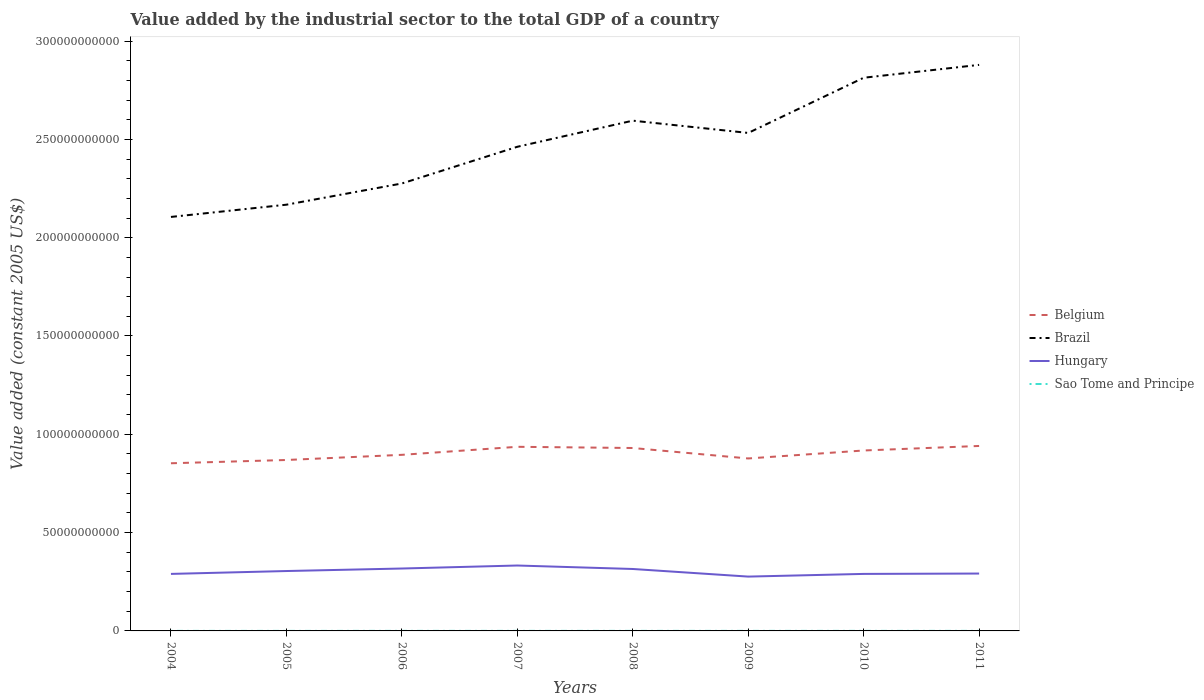How many different coloured lines are there?
Your answer should be very brief. 4. Does the line corresponding to Brazil intersect with the line corresponding to Hungary?
Offer a very short reply. No. Is the number of lines equal to the number of legend labels?
Keep it short and to the point. Yes. Across all years, what is the maximum value added by the industrial sector in Sao Tome and Principe?
Make the answer very short. 1.82e+07. In which year was the value added by the industrial sector in Sao Tome and Principe maximum?
Provide a short and direct response. 2004. What is the total value added by the industrial sector in Hungary in the graph?
Offer a very short reply. 4.04e+06. What is the difference between the highest and the second highest value added by the industrial sector in Hungary?
Provide a succinct answer. 5.64e+09. What is the difference between the highest and the lowest value added by the industrial sector in Brazil?
Make the answer very short. 4. How many lines are there?
Your response must be concise. 4. How many years are there in the graph?
Your answer should be very brief. 8. What is the difference between two consecutive major ticks on the Y-axis?
Your response must be concise. 5.00e+1. Are the values on the major ticks of Y-axis written in scientific E-notation?
Provide a short and direct response. No. Does the graph contain grids?
Offer a terse response. No. Where does the legend appear in the graph?
Your response must be concise. Center right. What is the title of the graph?
Your response must be concise. Value added by the industrial sector to the total GDP of a country. What is the label or title of the X-axis?
Keep it short and to the point. Years. What is the label or title of the Y-axis?
Your response must be concise. Value added (constant 2005 US$). What is the Value added (constant 2005 US$) of Belgium in 2004?
Offer a very short reply. 8.53e+1. What is the Value added (constant 2005 US$) in Brazil in 2004?
Make the answer very short. 2.11e+11. What is the Value added (constant 2005 US$) of Hungary in 2004?
Your answer should be compact. 2.90e+1. What is the Value added (constant 2005 US$) in Sao Tome and Principe in 2004?
Offer a terse response. 1.82e+07. What is the Value added (constant 2005 US$) of Belgium in 2005?
Your answer should be compact. 8.69e+1. What is the Value added (constant 2005 US$) in Brazil in 2005?
Ensure brevity in your answer.  2.17e+11. What is the Value added (constant 2005 US$) in Hungary in 2005?
Provide a short and direct response. 3.05e+1. What is the Value added (constant 2005 US$) of Sao Tome and Principe in 2005?
Offer a terse response. 1.89e+07. What is the Value added (constant 2005 US$) of Belgium in 2006?
Make the answer very short. 8.96e+1. What is the Value added (constant 2005 US$) in Brazil in 2006?
Provide a short and direct response. 2.28e+11. What is the Value added (constant 2005 US$) of Hungary in 2006?
Your answer should be very brief. 3.17e+1. What is the Value added (constant 2005 US$) in Sao Tome and Principe in 2006?
Keep it short and to the point. 2.01e+07. What is the Value added (constant 2005 US$) of Belgium in 2007?
Keep it short and to the point. 9.36e+1. What is the Value added (constant 2005 US$) in Brazil in 2007?
Make the answer very short. 2.46e+11. What is the Value added (constant 2005 US$) of Hungary in 2007?
Your answer should be compact. 3.33e+1. What is the Value added (constant 2005 US$) of Sao Tome and Principe in 2007?
Ensure brevity in your answer.  2.07e+07. What is the Value added (constant 2005 US$) in Belgium in 2008?
Provide a succinct answer. 9.30e+1. What is the Value added (constant 2005 US$) of Brazil in 2008?
Make the answer very short. 2.60e+11. What is the Value added (constant 2005 US$) in Hungary in 2008?
Make the answer very short. 3.15e+1. What is the Value added (constant 2005 US$) of Sao Tome and Principe in 2008?
Your answer should be very brief. 2.19e+07. What is the Value added (constant 2005 US$) of Belgium in 2009?
Offer a very short reply. 8.77e+1. What is the Value added (constant 2005 US$) of Brazil in 2009?
Ensure brevity in your answer.  2.53e+11. What is the Value added (constant 2005 US$) of Hungary in 2009?
Your response must be concise. 2.76e+1. What is the Value added (constant 2005 US$) of Sao Tome and Principe in 2009?
Offer a very short reply. 2.21e+07. What is the Value added (constant 2005 US$) in Belgium in 2010?
Offer a terse response. 9.18e+1. What is the Value added (constant 2005 US$) of Brazil in 2010?
Your response must be concise. 2.81e+11. What is the Value added (constant 2005 US$) of Hungary in 2010?
Keep it short and to the point. 2.90e+1. What is the Value added (constant 2005 US$) of Sao Tome and Principe in 2010?
Your response must be concise. 2.26e+07. What is the Value added (constant 2005 US$) in Belgium in 2011?
Your answer should be very brief. 9.41e+1. What is the Value added (constant 2005 US$) in Brazil in 2011?
Your answer should be compact. 2.88e+11. What is the Value added (constant 2005 US$) in Hungary in 2011?
Provide a succinct answer. 2.92e+1. What is the Value added (constant 2005 US$) of Sao Tome and Principe in 2011?
Give a very brief answer. 2.38e+07. Across all years, what is the maximum Value added (constant 2005 US$) of Belgium?
Make the answer very short. 9.41e+1. Across all years, what is the maximum Value added (constant 2005 US$) of Brazil?
Make the answer very short. 2.88e+11. Across all years, what is the maximum Value added (constant 2005 US$) in Hungary?
Provide a short and direct response. 3.33e+1. Across all years, what is the maximum Value added (constant 2005 US$) in Sao Tome and Principe?
Provide a short and direct response. 2.38e+07. Across all years, what is the minimum Value added (constant 2005 US$) of Belgium?
Your response must be concise. 8.53e+1. Across all years, what is the minimum Value added (constant 2005 US$) in Brazil?
Your answer should be very brief. 2.11e+11. Across all years, what is the minimum Value added (constant 2005 US$) of Hungary?
Your response must be concise. 2.76e+1. Across all years, what is the minimum Value added (constant 2005 US$) in Sao Tome and Principe?
Your response must be concise. 1.82e+07. What is the total Value added (constant 2005 US$) of Belgium in the graph?
Make the answer very short. 7.22e+11. What is the total Value added (constant 2005 US$) of Brazil in the graph?
Provide a short and direct response. 1.98e+12. What is the total Value added (constant 2005 US$) in Hungary in the graph?
Keep it short and to the point. 2.42e+11. What is the total Value added (constant 2005 US$) of Sao Tome and Principe in the graph?
Your answer should be very brief. 1.68e+08. What is the difference between the Value added (constant 2005 US$) in Belgium in 2004 and that in 2005?
Provide a succinct answer. -1.67e+09. What is the difference between the Value added (constant 2005 US$) in Brazil in 2004 and that in 2005?
Provide a short and direct response. -6.22e+09. What is the difference between the Value added (constant 2005 US$) of Hungary in 2004 and that in 2005?
Make the answer very short. -1.46e+09. What is the difference between the Value added (constant 2005 US$) in Sao Tome and Principe in 2004 and that in 2005?
Give a very brief answer. -6.98e+05. What is the difference between the Value added (constant 2005 US$) of Belgium in 2004 and that in 2006?
Give a very brief answer. -4.29e+09. What is the difference between the Value added (constant 2005 US$) of Brazil in 2004 and that in 2006?
Your response must be concise. -1.70e+1. What is the difference between the Value added (constant 2005 US$) of Hungary in 2004 and that in 2006?
Your response must be concise. -2.74e+09. What is the difference between the Value added (constant 2005 US$) of Sao Tome and Principe in 2004 and that in 2006?
Provide a succinct answer. -1.91e+06. What is the difference between the Value added (constant 2005 US$) in Belgium in 2004 and that in 2007?
Your answer should be compact. -8.37e+09. What is the difference between the Value added (constant 2005 US$) of Brazil in 2004 and that in 2007?
Give a very brief answer. -3.57e+1. What is the difference between the Value added (constant 2005 US$) in Hungary in 2004 and that in 2007?
Give a very brief answer. -4.27e+09. What is the difference between the Value added (constant 2005 US$) of Sao Tome and Principe in 2004 and that in 2007?
Make the answer very short. -2.48e+06. What is the difference between the Value added (constant 2005 US$) of Belgium in 2004 and that in 2008?
Your answer should be compact. -7.76e+09. What is the difference between the Value added (constant 2005 US$) in Brazil in 2004 and that in 2008?
Keep it short and to the point. -4.90e+1. What is the difference between the Value added (constant 2005 US$) in Hungary in 2004 and that in 2008?
Ensure brevity in your answer.  -2.50e+09. What is the difference between the Value added (constant 2005 US$) in Sao Tome and Principe in 2004 and that in 2008?
Ensure brevity in your answer.  -3.69e+06. What is the difference between the Value added (constant 2005 US$) of Belgium in 2004 and that in 2009?
Give a very brief answer. -2.44e+09. What is the difference between the Value added (constant 2005 US$) in Brazil in 2004 and that in 2009?
Your answer should be compact. -4.27e+1. What is the difference between the Value added (constant 2005 US$) of Hungary in 2004 and that in 2009?
Provide a succinct answer. 1.37e+09. What is the difference between the Value added (constant 2005 US$) of Sao Tome and Principe in 2004 and that in 2009?
Your answer should be very brief. -3.84e+06. What is the difference between the Value added (constant 2005 US$) of Belgium in 2004 and that in 2010?
Ensure brevity in your answer.  -6.50e+09. What is the difference between the Value added (constant 2005 US$) of Brazil in 2004 and that in 2010?
Offer a very short reply. -7.08e+1. What is the difference between the Value added (constant 2005 US$) in Hungary in 2004 and that in 2010?
Offer a very short reply. 4.04e+06. What is the difference between the Value added (constant 2005 US$) of Sao Tome and Principe in 2004 and that in 2010?
Give a very brief answer. -4.36e+06. What is the difference between the Value added (constant 2005 US$) of Belgium in 2004 and that in 2011?
Your response must be concise. -8.80e+09. What is the difference between the Value added (constant 2005 US$) in Brazil in 2004 and that in 2011?
Your answer should be compact. -7.73e+1. What is the difference between the Value added (constant 2005 US$) of Hungary in 2004 and that in 2011?
Offer a very short reply. -1.81e+08. What is the difference between the Value added (constant 2005 US$) in Sao Tome and Principe in 2004 and that in 2011?
Keep it short and to the point. -5.57e+06. What is the difference between the Value added (constant 2005 US$) of Belgium in 2005 and that in 2006?
Your response must be concise. -2.62e+09. What is the difference between the Value added (constant 2005 US$) in Brazil in 2005 and that in 2006?
Your response must be concise. -1.08e+1. What is the difference between the Value added (constant 2005 US$) in Hungary in 2005 and that in 2006?
Provide a succinct answer. -1.28e+09. What is the difference between the Value added (constant 2005 US$) of Sao Tome and Principe in 2005 and that in 2006?
Provide a succinct answer. -1.22e+06. What is the difference between the Value added (constant 2005 US$) in Belgium in 2005 and that in 2007?
Your answer should be compact. -6.70e+09. What is the difference between the Value added (constant 2005 US$) of Brazil in 2005 and that in 2007?
Your response must be concise. -2.95e+1. What is the difference between the Value added (constant 2005 US$) in Hungary in 2005 and that in 2007?
Ensure brevity in your answer.  -2.81e+09. What is the difference between the Value added (constant 2005 US$) of Sao Tome and Principe in 2005 and that in 2007?
Provide a short and direct response. -1.78e+06. What is the difference between the Value added (constant 2005 US$) of Belgium in 2005 and that in 2008?
Offer a very short reply. -6.09e+09. What is the difference between the Value added (constant 2005 US$) in Brazil in 2005 and that in 2008?
Offer a terse response. -4.27e+1. What is the difference between the Value added (constant 2005 US$) in Hungary in 2005 and that in 2008?
Keep it short and to the point. -1.04e+09. What is the difference between the Value added (constant 2005 US$) of Sao Tome and Principe in 2005 and that in 2008?
Keep it short and to the point. -2.99e+06. What is the difference between the Value added (constant 2005 US$) in Belgium in 2005 and that in 2009?
Keep it short and to the point. -7.76e+08. What is the difference between the Value added (constant 2005 US$) of Brazil in 2005 and that in 2009?
Your response must be concise. -3.65e+1. What is the difference between the Value added (constant 2005 US$) in Hungary in 2005 and that in 2009?
Keep it short and to the point. 2.83e+09. What is the difference between the Value added (constant 2005 US$) in Sao Tome and Principe in 2005 and that in 2009?
Your response must be concise. -3.15e+06. What is the difference between the Value added (constant 2005 US$) in Belgium in 2005 and that in 2010?
Offer a terse response. -4.83e+09. What is the difference between the Value added (constant 2005 US$) in Brazil in 2005 and that in 2010?
Keep it short and to the point. -6.46e+1. What is the difference between the Value added (constant 2005 US$) in Hungary in 2005 and that in 2010?
Provide a succinct answer. 1.47e+09. What is the difference between the Value added (constant 2005 US$) of Sao Tome and Principe in 2005 and that in 2010?
Offer a terse response. -3.66e+06. What is the difference between the Value added (constant 2005 US$) of Belgium in 2005 and that in 2011?
Your answer should be compact. -7.14e+09. What is the difference between the Value added (constant 2005 US$) in Brazil in 2005 and that in 2011?
Your answer should be very brief. -7.11e+1. What is the difference between the Value added (constant 2005 US$) in Hungary in 2005 and that in 2011?
Ensure brevity in your answer.  1.28e+09. What is the difference between the Value added (constant 2005 US$) of Sao Tome and Principe in 2005 and that in 2011?
Offer a very short reply. -4.87e+06. What is the difference between the Value added (constant 2005 US$) in Belgium in 2006 and that in 2007?
Your answer should be very brief. -4.08e+09. What is the difference between the Value added (constant 2005 US$) in Brazil in 2006 and that in 2007?
Give a very brief answer. -1.87e+1. What is the difference between the Value added (constant 2005 US$) in Hungary in 2006 and that in 2007?
Give a very brief answer. -1.53e+09. What is the difference between the Value added (constant 2005 US$) of Sao Tome and Principe in 2006 and that in 2007?
Give a very brief answer. -5.69e+05. What is the difference between the Value added (constant 2005 US$) in Belgium in 2006 and that in 2008?
Provide a short and direct response. -3.47e+09. What is the difference between the Value added (constant 2005 US$) of Brazil in 2006 and that in 2008?
Make the answer very short. -3.19e+1. What is the difference between the Value added (constant 2005 US$) of Hungary in 2006 and that in 2008?
Provide a succinct answer. 2.40e+08. What is the difference between the Value added (constant 2005 US$) in Sao Tome and Principe in 2006 and that in 2008?
Offer a very short reply. -1.78e+06. What is the difference between the Value added (constant 2005 US$) in Belgium in 2006 and that in 2009?
Your answer should be very brief. 1.84e+09. What is the difference between the Value added (constant 2005 US$) of Brazil in 2006 and that in 2009?
Your response must be concise. -2.57e+1. What is the difference between the Value added (constant 2005 US$) in Hungary in 2006 and that in 2009?
Offer a very short reply. 4.11e+09. What is the difference between the Value added (constant 2005 US$) in Sao Tome and Principe in 2006 and that in 2009?
Make the answer very short. -1.93e+06. What is the difference between the Value added (constant 2005 US$) of Belgium in 2006 and that in 2010?
Ensure brevity in your answer.  -2.21e+09. What is the difference between the Value added (constant 2005 US$) of Brazil in 2006 and that in 2010?
Your response must be concise. -5.38e+1. What is the difference between the Value added (constant 2005 US$) of Hungary in 2006 and that in 2010?
Your answer should be compact. 2.75e+09. What is the difference between the Value added (constant 2005 US$) in Sao Tome and Principe in 2006 and that in 2010?
Keep it short and to the point. -2.44e+06. What is the difference between the Value added (constant 2005 US$) of Belgium in 2006 and that in 2011?
Your answer should be very brief. -4.51e+09. What is the difference between the Value added (constant 2005 US$) in Brazil in 2006 and that in 2011?
Provide a succinct answer. -6.03e+1. What is the difference between the Value added (constant 2005 US$) of Hungary in 2006 and that in 2011?
Make the answer very short. 2.56e+09. What is the difference between the Value added (constant 2005 US$) in Sao Tome and Principe in 2006 and that in 2011?
Your answer should be compact. -3.65e+06. What is the difference between the Value added (constant 2005 US$) of Belgium in 2007 and that in 2008?
Make the answer very short. 6.09e+08. What is the difference between the Value added (constant 2005 US$) of Brazil in 2007 and that in 2008?
Provide a short and direct response. -1.33e+1. What is the difference between the Value added (constant 2005 US$) in Hungary in 2007 and that in 2008?
Offer a terse response. 1.77e+09. What is the difference between the Value added (constant 2005 US$) in Sao Tome and Principe in 2007 and that in 2008?
Offer a terse response. -1.21e+06. What is the difference between the Value added (constant 2005 US$) in Belgium in 2007 and that in 2009?
Provide a short and direct response. 5.93e+09. What is the difference between the Value added (constant 2005 US$) in Brazil in 2007 and that in 2009?
Provide a succinct answer. -7.04e+09. What is the difference between the Value added (constant 2005 US$) in Hungary in 2007 and that in 2009?
Your answer should be very brief. 5.64e+09. What is the difference between the Value added (constant 2005 US$) in Sao Tome and Principe in 2007 and that in 2009?
Offer a very short reply. -1.36e+06. What is the difference between the Value added (constant 2005 US$) of Belgium in 2007 and that in 2010?
Your answer should be very brief. 1.87e+09. What is the difference between the Value added (constant 2005 US$) in Brazil in 2007 and that in 2010?
Keep it short and to the point. -3.51e+1. What is the difference between the Value added (constant 2005 US$) in Hungary in 2007 and that in 2010?
Your response must be concise. 4.27e+09. What is the difference between the Value added (constant 2005 US$) of Sao Tome and Principe in 2007 and that in 2010?
Keep it short and to the point. -1.87e+06. What is the difference between the Value added (constant 2005 US$) of Belgium in 2007 and that in 2011?
Your answer should be compact. -4.31e+08. What is the difference between the Value added (constant 2005 US$) of Brazil in 2007 and that in 2011?
Offer a very short reply. -4.17e+1. What is the difference between the Value added (constant 2005 US$) in Hungary in 2007 and that in 2011?
Provide a short and direct response. 4.09e+09. What is the difference between the Value added (constant 2005 US$) of Sao Tome and Principe in 2007 and that in 2011?
Make the answer very short. -3.09e+06. What is the difference between the Value added (constant 2005 US$) of Belgium in 2008 and that in 2009?
Your response must be concise. 5.32e+09. What is the difference between the Value added (constant 2005 US$) of Brazil in 2008 and that in 2009?
Your response must be concise. 6.24e+09. What is the difference between the Value added (constant 2005 US$) of Hungary in 2008 and that in 2009?
Offer a very short reply. 3.87e+09. What is the difference between the Value added (constant 2005 US$) of Sao Tome and Principe in 2008 and that in 2009?
Offer a terse response. -1.52e+05. What is the difference between the Value added (constant 2005 US$) in Belgium in 2008 and that in 2010?
Keep it short and to the point. 1.26e+09. What is the difference between the Value added (constant 2005 US$) in Brazil in 2008 and that in 2010?
Provide a succinct answer. -2.18e+1. What is the difference between the Value added (constant 2005 US$) in Hungary in 2008 and that in 2010?
Offer a terse response. 2.51e+09. What is the difference between the Value added (constant 2005 US$) in Sao Tome and Principe in 2008 and that in 2010?
Offer a very short reply. -6.63e+05. What is the difference between the Value added (constant 2005 US$) in Belgium in 2008 and that in 2011?
Give a very brief answer. -1.04e+09. What is the difference between the Value added (constant 2005 US$) of Brazil in 2008 and that in 2011?
Offer a very short reply. -2.84e+1. What is the difference between the Value added (constant 2005 US$) of Hungary in 2008 and that in 2011?
Make the answer very short. 2.32e+09. What is the difference between the Value added (constant 2005 US$) of Sao Tome and Principe in 2008 and that in 2011?
Provide a succinct answer. -1.88e+06. What is the difference between the Value added (constant 2005 US$) of Belgium in 2009 and that in 2010?
Your answer should be very brief. -4.05e+09. What is the difference between the Value added (constant 2005 US$) of Brazil in 2009 and that in 2010?
Your answer should be compact. -2.81e+1. What is the difference between the Value added (constant 2005 US$) in Hungary in 2009 and that in 2010?
Your response must be concise. -1.37e+09. What is the difference between the Value added (constant 2005 US$) of Sao Tome and Principe in 2009 and that in 2010?
Offer a very short reply. -5.12e+05. What is the difference between the Value added (constant 2005 US$) in Belgium in 2009 and that in 2011?
Keep it short and to the point. -6.36e+09. What is the difference between the Value added (constant 2005 US$) of Brazil in 2009 and that in 2011?
Give a very brief answer. -3.46e+1. What is the difference between the Value added (constant 2005 US$) in Hungary in 2009 and that in 2011?
Make the answer very short. -1.55e+09. What is the difference between the Value added (constant 2005 US$) of Sao Tome and Principe in 2009 and that in 2011?
Provide a succinct answer. -1.72e+06. What is the difference between the Value added (constant 2005 US$) in Belgium in 2010 and that in 2011?
Offer a very short reply. -2.30e+09. What is the difference between the Value added (constant 2005 US$) in Brazil in 2010 and that in 2011?
Ensure brevity in your answer.  -6.54e+09. What is the difference between the Value added (constant 2005 US$) in Hungary in 2010 and that in 2011?
Offer a terse response. -1.85e+08. What is the difference between the Value added (constant 2005 US$) of Sao Tome and Principe in 2010 and that in 2011?
Provide a succinct answer. -1.21e+06. What is the difference between the Value added (constant 2005 US$) of Belgium in 2004 and the Value added (constant 2005 US$) of Brazil in 2005?
Keep it short and to the point. -1.32e+11. What is the difference between the Value added (constant 2005 US$) of Belgium in 2004 and the Value added (constant 2005 US$) of Hungary in 2005?
Ensure brevity in your answer.  5.48e+1. What is the difference between the Value added (constant 2005 US$) of Belgium in 2004 and the Value added (constant 2005 US$) of Sao Tome and Principe in 2005?
Ensure brevity in your answer.  8.52e+1. What is the difference between the Value added (constant 2005 US$) of Brazil in 2004 and the Value added (constant 2005 US$) of Hungary in 2005?
Offer a terse response. 1.80e+11. What is the difference between the Value added (constant 2005 US$) in Brazil in 2004 and the Value added (constant 2005 US$) in Sao Tome and Principe in 2005?
Your answer should be compact. 2.11e+11. What is the difference between the Value added (constant 2005 US$) in Hungary in 2004 and the Value added (constant 2005 US$) in Sao Tome and Principe in 2005?
Offer a very short reply. 2.90e+1. What is the difference between the Value added (constant 2005 US$) of Belgium in 2004 and the Value added (constant 2005 US$) of Brazil in 2006?
Provide a succinct answer. -1.42e+11. What is the difference between the Value added (constant 2005 US$) in Belgium in 2004 and the Value added (constant 2005 US$) in Hungary in 2006?
Keep it short and to the point. 5.35e+1. What is the difference between the Value added (constant 2005 US$) of Belgium in 2004 and the Value added (constant 2005 US$) of Sao Tome and Principe in 2006?
Ensure brevity in your answer.  8.52e+1. What is the difference between the Value added (constant 2005 US$) of Brazil in 2004 and the Value added (constant 2005 US$) of Hungary in 2006?
Your answer should be compact. 1.79e+11. What is the difference between the Value added (constant 2005 US$) of Brazil in 2004 and the Value added (constant 2005 US$) of Sao Tome and Principe in 2006?
Your response must be concise. 2.11e+11. What is the difference between the Value added (constant 2005 US$) in Hungary in 2004 and the Value added (constant 2005 US$) in Sao Tome and Principe in 2006?
Your response must be concise. 2.90e+1. What is the difference between the Value added (constant 2005 US$) of Belgium in 2004 and the Value added (constant 2005 US$) of Brazil in 2007?
Keep it short and to the point. -1.61e+11. What is the difference between the Value added (constant 2005 US$) of Belgium in 2004 and the Value added (constant 2005 US$) of Hungary in 2007?
Offer a terse response. 5.20e+1. What is the difference between the Value added (constant 2005 US$) of Belgium in 2004 and the Value added (constant 2005 US$) of Sao Tome and Principe in 2007?
Your answer should be compact. 8.52e+1. What is the difference between the Value added (constant 2005 US$) in Brazil in 2004 and the Value added (constant 2005 US$) in Hungary in 2007?
Your response must be concise. 1.77e+11. What is the difference between the Value added (constant 2005 US$) in Brazil in 2004 and the Value added (constant 2005 US$) in Sao Tome and Principe in 2007?
Make the answer very short. 2.11e+11. What is the difference between the Value added (constant 2005 US$) in Hungary in 2004 and the Value added (constant 2005 US$) in Sao Tome and Principe in 2007?
Offer a terse response. 2.90e+1. What is the difference between the Value added (constant 2005 US$) of Belgium in 2004 and the Value added (constant 2005 US$) of Brazil in 2008?
Keep it short and to the point. -1.74e+11. What is the difference between the Value added (constant 2005 US$) of Belgium in 2004 and the Value added (constant 2005 US$) of Hungary in 2008?
Offer a very short reply. 5.38e+1. What is the difference between the Value added (constant 2005 US$) of Belgium in 2004 and the Value added (constant 2005 US$) of Sao Tome and Principe in 2008?
Offer a terse response. 8.52e+1. What is the difference between the Value added (constant 2005 US$) in Brazil in 2004 and the Value added (constant 2005 US$) in Hungary in 2008?
Offer a very short reply. 1.79e+11. What is the difference between the Value added (constant 2005 US$) in Brazil in 2004 and the Value added (constant 2005 US$) in Sao Tome and Principe in 2008?
Make the answer very short. 2.11e+11. What is the difference between the Value added (constant 2005 US$) in Hungary in 2004 and the Value added (constant 2005 US$) in Sao Tome and Principe in 2008?
Your answer should be compact. 2.90e+1. What is the difference between the Value added (constant 2005 US$) in Belgium in 2004 and the Value added (constant 2005 US$) in Brazil in 2009?
Give a very brief answer. -1.68e+11. What is the difference between the Value added (constant 2005 US$) in Belgium in 2004 and the Value added (constant 2005 US$) in Hungary in 2009?
Provide a succinct answer. 5.76e+1. What is the difference between the Value added (constant 2005 US$) in Belgium in 2004 and the Value added (constant 2005 US$) in Sao Tome and Principe in 2009?
Give a very brief answer. 8.52e+1. What is the difference between the Value added (constant 2005 US$) in Brazil in 2004 and the Value added (constant 2005 US$) in Hungary in 2009?
Provide a succinct answer. 1.83e+11. What is the difference between the Value added (constant 2005 US$) of Brazil in 2004 and the Value added (constant 2005 US$) of Sao Tome and Principe in 2009?
Provide a short and direct response. 2.11e+11. What is the difference between the Value added (constant 2005 US$) of Hungary in 2004 and the Value added (constant 2005 US$) of Sao Tome and Principe in 2009?
Your answer should be very brief. 2.90e+1. What is the difference between the Value added (constant 2005 US$) in Belgium in 2004 and the Value added (constant 2005 US$) in Brazil in 2010?
Your response must be concise. -1.96e+11. What is the difference between the Value added (constant 2005 US$) in Belgium in 2004 and the Value added (constant 2005 US$) in Hungary in 2010?
Your answer should be compact. 5.63e+1. What is the difference between the Value added (constant 2005 US$) of Belgium in 2004 and the Value added (constant 2005 US$) of Sao Tome and Principe in 2010?
Provide a short and direct response. 8.52e+1. What is the difference between the Value added (constant 2005 US$) in Brazil in 2004 and the Value added (constant 2005 US$) in Hungary in 2010?
Provide a short and direct response. 1.82e+11. What is the difference between the Value added (constant 2005 US$) of Brazil in 2004 and the Value added (constant 2005 US$) of Sao Tome and Principe in 2010?
Give a very brief answer. 2.11e+11. What is the difference between the Value added (constant 2005 US$) of Hungary in 2004 and the Value added (constant 2005 US$) of Sao Tome and Principe in 2010?
Offer a terse response. 2.90e+1. What is the difference between the Value added (constant 2005 US$) in Belgium in 2004 and the Value added (constant 2005 US$) in Brazil in 2011?
Provide a short and direct response. -2.03e+11. What is the difference between the Value added (constant 2005 US$) of Belgium in 2004 and the Value added (constant 2005 US$) of Hungary in 2011?
Offer a terse response. 5.61e+1. What is the difference between the Value added (constant 2005 US$) of Belgium in 2004 and the Value added (constant 2005 US$) of Sao Tome and Principe in 2011?
Ensure brevity in your answer.  8.52e+1. What is the difference between the Value added (constant 2005 US$) of Brazil in 2004 and the Value added (constant 2005 US$) of Hungary in 2011?
Ensure brevity in your answer.  1.81e+11. What is the difference between the Value added (constant 2005 US$) in Brazil in 2004 and the Value added (constant 2005 US$) in Sao Tome and Principe in 2011?
Keep it short and to the point. 2.11e+11. What is the difference between the Value added (constant 2005 US$) in Hungary in 2004 and the Value added (constant 2005 US$) in Sao Tome and Principe in 2011?
Provide a succinct answer. 2.90e+1. What is the difference between the Value added (constant 2005 US$) of Belgium in 2005 and the Value added (constant 2005 US$) of Brazil in 2006?
Offer a terse response. -1.41e+11. What is the difference between the Value added (constant 2005 US$) in Belgium in 2005 and the Value added (constant 2005 US$) in Hungary in 2006?
Your answer should be very brief. 5.52e+1. What is the difference between the Value added (constant 2005 US$) of Belgium in 2005 and the Value added (constant 2005 US$) of Sao Tome and Principe in 2006?
Give a very brief answer. 8.69e+1. What is the difference between the Value added (constant 2005 US$) in Brazil in 2005 and the Value added (constant 2005 US$) in Hungary in 2006?
Offer a very short reply. 1.85e+11. What is the difference between the Value added (constant 2005 US$) of Brazil in 2005 and the Value added (constant 2005 US$) of Sao Tome and Principe in 2006?
Provide a short and direct response. 2.17e+11. What is the difference between the Value added (constant 2005 US$) in Hungary in 2005 and the Value added (constant 2005 US$) in Sao Tome and Principe in 2006?
Provide a short and direct response. 3.04e+1. What is the difference between the Value added (constant 2005 US$) in Belgium in 2005 and the Value added (constant 2005 US$) in Brazil in 2007?
Your answer should be compact. -1.59e+11. What is the difference between the Value added (constant 2005 US$) in Belgium in 2005 and the Value added (constant 2005 US$) in Hungary in 2007?
Your answer should be compact. 5.37e+1. What is the difference between the Value added (constant 2005 US$) in Belgium in 2005 and the Value added (constant 2005 US$) in Sao Tome and Principe in 2007?
Ensure brevity in your answer.  8.69e+1. What is the difference between the Value added (constant 2005 US$) in Brazil in 2005 and the Value added (constant 2005 US$) in Hungary in 2007?
Provide a short and direct response. 1.84e+11. What is the difference between the Value added (constant 2005 US$) of Brazil in 2005 and the Value added (constant 2005 US$) of Sao Tome and Principe in 2007?
Keep it short and to the point. 2.17e+11. What is the difference between the Value added (constant 2005 US$) in Hungary in 2005 and the Value added (constant 2005 US$) in Sao Tome and Principe in 2007?
Make the answer very short. 3.04e+1. What is the difference between the Value added (constant 2005 US$) in Belgium in 2005 and the Value added (constant 2005 US$) in Brazil in 2008?
Ensure brevity in your answer.  -1.73e+11. What is the difference between the Value added (constant 2005 US$) of Belgium in 2005 and the Value added (constant 2005 US$) of Hungary in 2008?
Your answer should be very brief. 5.54e+1. What is the difference between the Value added (constant 2005 US$) of Belgium in 2005 and the Value added (constant 2005 US$) of Sao Tome and Principe in 2008?
Your answer should be compact. 8.69e+1. What is the difference between the Value added (constant 2005 US$) of Brazil in 2005 and the Value added (constant 2005 US$) of Hungary in 2008?
Your response must be concise. 1.85e+11. What is the difference between the Value added (constant 2005 US$) of Brazil in 2005 and the Value added (constant 2005 US$) of Sao Tome and Principe in 2008?
Your response must be concise. 2.17e+11. What is the difference between the Value added (constant 2005 US$) of Hungary in 2005 and the Value added (constant 2005 US$) of Sao Tome and Principe in 2008?
Your response must be concise. 3.04e+1. What is the difference between the Value added (constant 2005 US$) of Belgium in 2005 and the Value added (constant 2005 US$) of Brazil in 2009?
Provide a succinct answer. -1.66e+11. What is the difference between the Value added (constant 2005 US$) of Belgium in 2005 and the Value added (constant 2005 US$) of Hungary in 2009?
Your response must be concise. 5.93e+1. What is the difference between the Value added (constant 2005 US$) in Belgium in 2005 and the Value added (constant 2005 US$) in Sao Tome and Principe in 2009?
Your answer should be compact. 8.69e+1. What is the difference between the Value added (constant 2005 US$) of Brazil in 2005 and the Value added (constant 2005 US$) of Hungary in 2009?
Provide a short and direct response. 1.89e+11. What is the difference between the Value added (constant 2005 US$) in Brazil in 2005 and the Value added (constant 2005 US$) in Sao Tome and Principe in 2009?
Your answer should be very brief. 2.17e+11. What is the difference between the Value added (constant 2005 US$) of Hungary in 2005 and the Value added (constant 2005 US$) of Sao Tome and Principe in 2009?
Provide a short and direct response. 3.04e+1. What is the difference between the Value added (constant 2005 US$) of Belgium in 2005 and the Value added (constant 2005 US$) of Brazil in 2010?
Ensure brevity in your answer.  -1.94e+11. What is the difference between the Value added (constant 2005 US$) in Belgium in 2005 and the Value added (constant 2005 US$) in Hungary in 2010?
Give a very brief answer. 5.79e+1. What is the difference between the Value added (constant 2005 US$) of Belgium in 2005 and the Value added (constant 2005 US$) of Sao Tome and Principe in 2010?
Provide a short and direct response. 8.69e+1. What is the difference between the Value added (constant 2005 US$) in Brazil in 2005 and the Value added (constant 2005 US$) in Hungary in 2010?
Your response must be concise. 1.88e+11. What is the difference between the Value added (constant 2005 US$) of Brazil in 2005 and the Value added (constant 2005 US$) of Sao Tome and Principe in 2010?
Your answer should be very brief. 2.17e+11. What is the difference between the Value added (constant 2005 US$) of Hungary in 2005 and the Value added (constant 2005 US$) of Sao Tome and Principe in 2010?
Give a very brief answer. 3.04e+1. What is the difference between the Value added (constant 2005 US$) in Belgium in 2005 and the Value added (constant 2005 US$) in Brazil in 2011?
Give a very brief answer. -2.01e+11. What is the difference between the Value added (constant 2005 US$) in Belgium in 2005 and the Value added (constant 2005 US$) in Hungary in 2011?
Make the answer very short. 5.78e+1. What is the difference between the Value added (constant 2005 US$) in Belgium in 2005 and the Value added (constant 2005 US$) in Sao Tome and Principe in 2011?
Offer a very short reply. 8.69e+1. What is the difference between the Value added (constant 2005 US$) of Brazil in 2005 and the Value added (constant 2005 US$) of Hungary in 2011?
Ensure brevity in your answer.  1.88e+11. What is the difference between the Value added (constant 2005 US$) in Brazil in 2005 and the Value added (constant 2005 US$) in Sao Tome and Principe in 2011?
Give a very brief answer. 2.17e+11. What is the difference between the Value added (constant 2005 US$) in Hungary in 2005 and the Value added (constant 2005 US$) in Sao Tome and Principe in 2011?
Keep it short and to the point. 3.04e+1. What is the difference between the Value added (constant 2005 US$) of Belgium in 2006 and the Value added (constant 2005 US$) of Brazil in 2007?
Ensure brevity in your answer.  -1.57e+11. What is the difference between the Value added (constant 2005 US$) in Belgium in 2006 and the Value added (constant 2005 US$) in Hungary in 2007?
Provide a succinct answer. 5.63e+1. What is the difference between the Value added (constant 2005 US$) in Belgium in 2006 and the Value added (constant 2005 US$) in Sao Tome and Principe in 2007?
Give a very brief answer. 8.95e+1. What is the difference between the Value added (constant 2005 US$) of Brazil in 2006 and the Value added (constant 2005 US$) of Hungary in 2007?
Provide a short and direct response. 1.94e+11. What is the difference between the Value added (constant 2005 US$) in Brazil in 2006 and the Value added (constant 2005 US$) in Sao Tome and Principe in 2007?
Your answer should be compact. 2.28e+11. What is the difference between the Value added (constant 2005 US$) of Hungary in 2006 and the Value added (constant 2005 US$) of Sao Tome and Principe in 2007?
Your response must be concise. 3.17e+1. What is the difference between the Value added (constant 2005 US$) in Belgium in 2006 and the Value added (constant 2005 US$) in Brazil in 2008?
Offer a terse response. -1.70e+11. What is the difference between the Value added (constant 2005 US$) in Belgium in 2006 and the Value added (constant 2005 US$) in Hungary in 2008?
Give a very brief answer. 5.81e+1. What is the difference between the Value added (constant 2005 US$) in Belgium in 2006 and the Value added (constant 2005 US$) in Sao Tome and Principe in 2008?
Your response must be concise. 8.95e+1. What is the difference between the Value added (constant 2005 US$) in Brazil in 2006 and the Value added (constant 2005 US$) in Hungary in 2008?
Your response must be concise. 1.96e+11. What is the difference between the Value added (constant 2005 US$) of Brazil in 2006 and the Value added (constant 2005 US$) of Sao Tome and Principe in 2008?
Your answer should be compact. 2.28e+11. What is the difference between the Value added (constant 2005 US$) in Hungary in 2006 and the Value added (constant 2005 US$) in Sao Tome and Principe in 2008?
Offer a terse response. 3.17e+1. What is the difference between the Value added (constant 2005 US$) in Belgium in 2006 and the Value added (constant 2005 US$) in Brazil in 2009?
Keep it short and to the point. -1.64e+11. What is the difference between the Value added (constant 2005 US$) of Belgium in 2006 and the Value added (constant 2005 US$) of Hungary in 2009?
Offer a very short reply. 6.19e+1. What is the difference between the Value added (constant 2005 US$) in Belgium in 2006 and the Value added (constant 2005 US$) in Sao Tome and Principe in 2009?
Your answer should be very brief. 8.95e+1. What is the difference between the Value added (constant 2005 US$) of Brazil in 2006 and the Value added (constant 2005 US$) of Hungary in 2009?
Keep it short and to the point. 2.00e+11. What is the difference between the Value added (constant 2005 US$) in Brazil in 2006 and the Value added (constant 2005 US$) in Sao Tome and Principe in 2009?
Your response must be concise. 2.28e+11. What is the difference between the Value added (constant 2005 US$) of Hungary in 2006 and the Value added (constant 2005 US$) of Sao Tome and Principe in 2009?
Keep it short and to the point. 3.17e+1. What is the difference between the Value added (constant 2005 US$) in Belgium in 2006 and the Value added (constant 2005 US$) in Brazil in 2010?
Your answer should be very brief. -1.92e+11. What is the difference between the Value added (constant 2005 US$) in Belgium in 2006 and the Value added (constant 2005 US$) in Hungary in 2010?
Provide a succinct answer. 6.06e+1. What is the difference between the Value added (constant 2005 US$) of Belgium in 2006 and the Value added (constant 2005 US$) of Sao Tome and Principe in 2010?
Your response must be concise. 8.95e+1. What is the difference between the Value added (constant 2005 US$) of Brazil in 2006 and the Value added (constant 2005 US$) of Hungary in 2010?
Provide a short and direct response. 1.99e+11. What is the difference between the Value added (constant 2005 US$) of Brazil in 2006 and the Value added (constant 2005 US$) of Sao Tome and Principe in 2010?
Ensure brevity in your answer.  2.28e+11. What is the difference between the Value added (constant 2005 US$) in Hungary in 2006 and the Value added (constant 2005 US$) in Sao Tome and Principe in 2010?
Ensure brevity in your answer.  3.17e+1. What is the difference between the Value added (constant 2005 US$) in Belgium in 2006 and the Value added (constant 2005 US$) in Brazil in 2011?
Give a very brief answer. -1.98e+11. What is the difference between the Value added (constant 2005 US$) of Belgium in 2006 and the Value added (constant 2005 US$) of Hungary in 2011?
Provide a short and direct response. 6.04e+1. What is the difference between the Value added (constant 2005 US$) in Belgium in 2006 and the Value added (constant 2005 US$) in Sao Tome and Principe in 2011?
Offer a terse response. 8.95e+1. What is the difference between the Value added (constant 2005 US$) of Brazil in 2006 and the Value added (constant 2005 US$) of Hungary in 2011?
Your answer should be very brief. 1.98e+11. What is the difference between the Value added (constant 2005 US$) in Brazil in 2006 and the Value added (constant 2005 US$) in Sao Tome and Principe in 2011?
Your answer should be compact. 2.28e+11. What is the difference between the Value added (constant 2005 US$) of Hungary in 2006 and the Value added (constant 2005 US$) of Sao Tome and Principe in 2011?
Give a very brief answer. 3.17e+1. What is the difference between the Value added (constant 2005 US$) of Belgium in 2007 and the Value added (constant 2005 US$) of Brazil in 2008?
Offer a terse response. -1.66e+11. What is the difference between the Value added (constant 2005 US$) in Belgium in 2007 and the Value added (constant 2005 US$) in Hungary in 2008?
Provide a short and direct response. 6.21e+1. What is the difference between the Value added (constant 2005 US$) in Belgium in 2007 and the Value added (constant 2005 US$) in Sao Tome and Principe in 2008?
Your response must be concise. 9.36e+1. What is the difference between the Value added (constant 2005 US$) of Brazil in 2007 and the Value added (constant 2005 US$) of Hungary in 2008?
Provide a short and direct response. 2.15e+11. What is the difference between the Value added (constant 2005 US$) of Brazil in 2007 and the Value added (constant 2005 US$) of Sao Tome and Principe in 2008?
Offer a terse response. 2.46e+11. What is the difference between the Value added (constant 2005 US$) in Hungary in 2007 and the Value added (constant 2005 US$) in Sao Tome and Principe in 2008?
Provide a short and direct response. 3.32e+1. What is the difference between the Value added (constant 2005 US$) of Belgium in 2007 and the Value added (constant 2005 US$) of Brazil in 2009?
Your answer should be very brief. -1.60e+11. What is the difference between the Value added (constant 2005 US$) in Belgium in 2007 and the Value added (constant 2005 US$) in Hungary in 2009?
Your answer should be very brief. 6.60e+1. What is the difference between the Value added (constant 2005 US$) of Belgium in 2007 and the Value added (constant 2005 US$) of Sao Tome and Principe in 2009?
Your response must be concise. 9.36e+1. What is the difference between the Value added (constant 2005 US$) of Brazil in 2007 and the Value added (constant 2005 US$) of Hungary in 2009?
Give a very brief answer. 2.19e+11. What is the difference between the Value added (constant 2005 US$) of Brazil in 2007 and the Value added (constant 2005 US$) of Sao Tome and Principe in 2009?
Make the answer very short. 2.46e+11. What is the difference between the Value added (constant 2005 US$) in Hungary in 2007 and the Value added (constant 2005 US$) in Sao Tome and Principe in 2009?
Your answer should be compact. 3.32e+1. What is the difference between the Value added (constant 2005 US$) in Belgium in 2007 and the Value added (constant 2005 US$) in Brazil in 2010?
Your answer should be compact. -1.88e+11. What is the difference between the Value added (constant 2005 US$) of Belgium in 2007 and the Value added (constant 2005 US$) of Hungary in 2010?
Make the answer very short. 6.46e+1. What is the difference between the Value added (constant 2005 US$) in Belgium in 2007 and the Value added (constant 2005 US$) in Sao Tome and Principe in 2010?
Provide a succinct answer. 9.36e+1. What is the difference between the Value added (constant 2005 US$) in Brazil in 2007 and the Value added (constant 2005 US$) in Hungary in 2010?
Keep it short and to the point. 2.17e+11. What is the difference between the Value added (constant 2005 US$) of Brazil in 2007 and the Value added (constant 2005 US$) of Sao Tome and Principe in 2010?
Your answer should be compact. 2.46e+11. What is the difference between the Value added (constant 2005 US$) of Hungary in 2007 and the Value added (constant 2005 US$) of Sao Tome and Principe in 2010?
Your response must be concise. 3.32e+1. What is the difference between the Value added (constant 2005 US$) of Belgium in 2007 and the Value added (constant 2005 US$) of Brazil in 2011?
Your response must be concise. -1.94e+11. What is the difference between the Value added (constant 2005 US$) of Belgium in 2007 and the Value added (constant 2005 US$) of Hungary in 2011?
Provide a succinct answer. 6.45e+1. What is the difference between the Value added (constant 2005 US$) of Belgium in 2007 and the Value added (constant 2005 US$) of Sao Tome and Principe in 2011?
Your answer should be very brief. 9.36e+1. What is the difference between the Value added (constant 2005 US$) of Brazil in 2007 and the Value added (constant 2005 US$) of Hungary in 2011?
Offer a terse response. 2.17e+11. What is the difference between the Value added (constant 2005 US$) of Brazil in 2007 and the Value added (constant 2005 US$) of Sao Tome and Principe in 2011?
Give a very brief answer. 2.46e+11. What is the difference between the Value added (constant 2005 US$) in Hungary in 2007 and the Value added (constant 2005 US$) in Sao Tome and Principe in 2011?
Offer a terse response. 3.32e+1. What is the difference between the Value added (constant 2005 US$) of Belgium in 2008 and the Value added (constant 2005 US$) of Brazil in 2009?
Your response must be concise. -1.60e+11. What is the difference between the Value added (constant 2005 US$) of Belgium in 2008 and the Value added (constant 2005 US$) of Hungary in 2009?
Your answer should be very brief. 6.54e+1. What is the difference between the Value added (constant 2005 US$) of Belgium in 2008 and the Value added (constant 2005 US$) of Sao Tome and Principe in 2009?
Provide a short and direct response. 9.30e+1. What is the difference between the Value added (constant 2005 US$) of Brazil in 2008 and the Value added (constant 2005 US$) of Hungary in 2009?
Ensure brevity in your answer.  2.32e+11. What is the difference between the Value added (constant 2005 US$) in Brazil in 2008 and the Value added (constant 2005 US$) in Sao Tome and Principe in 2009?
Make the answer very short. 2.59e+11. What is the difference between the Value added (constant 2005 US$) in Hungary in 2008 and the Value added (constant 2005 US$) in Sao Tome and Principe in 2009?
Provide a short and direct response. 3.15e+1. What is the difference between the Value added (constant 2005 US$) of Belgium in 2008 and the Value added (constant 2005 US$) of Brazil in 2010?
Your response must be concise. -1.88e+11. What is the difference between the Value added (constant 2005 US$) of Belgium in 2008 and the Value added (constant 2005 US$) of Hungary in 2010?
Your response must be concise. 6.40e+1. What is the difference between the Value added (constant 2005 US$) in Belgium in 2008 and the Value added (constant 2005 US$) in Sao Tome and Principe in 2010?
Offer a terse response. 9.30e+1. What is the difference between the Value added (constant 2005 US$) in Brazil in 2008 and the Value added (constant 2005 US$) in Hungary in 2010?
Your answer should be compact. 2.31e+11. What is the difference between the Value added (constant 2005 US$) of Brazil in 2008 and the Value added (constant 2005 US$) of Sao Tome and Principe in 2010?
Your answer should be compact. 2.59e+11. What is the difference between the Value added (constant 2005 US$) of Hungary in 2008 and the Value added (constant 2005 US$) of Sao Tome and Principe in 2010?
Give a very brief answer. 3.15e+1. What is the difference between the Value added (constant 2005 US$) in Belgium in 2008 and the Value added (constant 2005 US$) in Brazil in 2011?
Offer a terse response. -1.95e+11. What is the difference between the Value added (constant 2005 US$) in Belgium in 2008 and the Value added (constant 2005 US$) in Hungary in 2011?
Provide a succinct answer. 6.38e+1. What is the difference between the Value added (constant 2005 US$) of Belgium in 2008 and the Value added (constant 2005 US$) of Sao Tome and Principe in 2011?
Offer a terse response. 9.30e+1. What is the difference between the Value added (constant 2005 US$) of Brazil in 2008 and the Value added (constant 2005 US$) of Hungary in 2011?
Your response must be concise. 2.30e+11. What is the difference between the Value added (constant 2005 US$) of Brazil in 2008 and the Value added (constant 2005 US$) of Sao Tome and Principe in 2011?
Provide a succinct answer. 2.59e+11. What is the difference between the Value added (constant 2005 US$) of Hungary in 2008 and the Value added (constant 2005 US$) of Sao Tome and Principe in 2011?
Your answer should be compact. 3.15e+1. What is the difference between the Value added (constant 2005 US$) of Belgium in 2009 and the Value added (constant 2005 US$) of Brazil in 2010?
Your answer should be compact. -1.94e+11. What is the difference between the Value added (constant 2005 US$) of Belgium in 2009 and the Value added (constant 2005 US$) of Hungary in 2010?
Provide a short and direct response. 5.87e+1. What is the difference between the Value added (constant 2005 US$) in Belgium in 2009 and the Value added (constant 2005 US$) in Sao Tome and Principe in 2010?
Provide a short and direct response. 8.77e+1. What is the difference between the Value added (constant 2005 US$) in Brazil in 2009 and the Value added (constant 2005 US$) in Hungary in 2010?
Give a very brief answer. 2.24e+11. What is the difference between the Value added (constant 2005 US$) in Brazil in 2009 and the Value added (constant 2005 US$) in Sao Tome and Principe in 2010?
Make the answer very short. 2.53e+11. What is the difference between the Value added (constant 2005 US$) in Hungary in 2009 and the Value added (constant 2005 US$) in Sao Tome and Principe in 2010?
Give a very brief answer. 2.76e+1. What is the difference between the Value added (constant 2005 US$) in Belgium in 2009 and the Value added (constant 2005 US$) in Brazil in 2011?
Keep it short and to the point. -2.00e+11. What is the difference between the Value added (constant 2005 US$) of Belgium in 2009 and the Value added (constant 2005 US$) of Hungary in 2011?
Make the answer very short. 5.85e+1. What is the difference between the Value added (constant 2005 US$) in Belgium in 2009 and the Value added (constant 2005 US$) in Sao Tome and Principe in 2011?
Keep it short and to the point. 8.77e+1. What is the difference between the Value added (constant 2005 US$) in Brazil in 2009 and the Value added (constant 2005 US$) in Hungary in 2011?
Keep it short and to the point. 2.24e+11. What is the difference between the Value added (constant 2005 US$) in Brazil in 2009 and the Value added (constant 2005 US$) in Sao Tome and Principe in 2011?
Offer a terse response. 2.53e+11. What is the difference between the Value added (constant 2005 US$) of Hungary in 2009 and the Value added (constant 2005 US$) of Sao Tome and Principe in 2011?
Your answer should be compact. 2.76e+1. What is the difference between the Value added (constant 2005 US$) of Belgium in 2010 and the Value added (constant 2005 US$) of Brazil in 2011?
Provide a short and direct response. -1.96e+11. What is the difference between the Value added (constant 2005 US$) in Belgium in 2010 and the Value added (constant 2005 US$) in Hungary in 2011?
Offer a very short reply. 6.26e+1. What is the difference between the Value added (constant 2005 US$) in Belgium in 2010 and the Value added (constant 2005 US$) in Sao Tome and Principe in 2011?
Your answer should be compact. 9.17e+1. What is the difference between the Value added (constant 2005 US$) in Brazil in 2010 and the Value added (constant 2005 US$) in Hungary in 2011?
Make the answer very short. 2.52e+11. What is the difference between the Value added (constant 2005 US$) in Brazil in 2010 and the Value added (constant 2005 US$) in Sao Tome and Principe in 2011?
Offer a very short reply. 2.81e+11. What is the difference between the Value added (constant 2005 US$) of Hungary in 2010 and the Value added (constant 2005 US$) of Sao Tome and Principe in 2011?
Keep it short and to the point. 2.90e+1. What is the average Value added (constant 2005 US$) of Belgium per year?
Your answer should be compact. 9.02e+1. What is the average Value added (constant 2005 US$) of Brazil per year?
Give a very brief answer. 2.48e+11. What is the average Value added (constant 2005 US$) in Hungary per year?
Keep it short and to the point. 3.02e+1. What is the average Value added (constant 2005 US$) of Sao Tome and Principe per year?
Give a very brief answer. 2.11e+07. In the year 2004, what is the difference between the Value added (constant 2005 US$) in Belgium and Value added (constant 2005 US$) in Brazil?
Provide a short and direct response. -1.25e+11. In the year 2004, what is the difference between the Value added (constant 2005 US$) in Belgium and Value added (constant 2005 US$) in Hungary?
Provide a short and direct response. 5.63e+1. In the year 2004, what is the difference between the Value added (constant 2005 US$) of Belgium and Value added (constant 2005 US$) of Sao Tome and Principe?
Offer a very short reply. 8.53e+1. In the year 2004, what is the difference between the Value added (constant 2005 US$) of Brazil and Value added (constant 2005 US$) of Hungary?
Give a very brief answer. 1.82e+11. In the year 2004, what is the difference between the Value added (constant 2005 US$) in Brazil and Value added (constant 2005 US$) in Sao Tome and Principe?
Ensure brevity in your answer.  2.11e+11. In the year 2004, what is the difference between the Value added (constant 2005 US$) of Hungary and Value added (constant 2005 US$) of Sao Tome and Principe?
Offer a terse response. 2.90e+1. In the year 2005, what is the difference between the Value added (constant 2005 US$) of Belgium and Value added (constant 2005 US$) of Brazil?
Your response must be concise. -1.30e+11. In the year 2005, what is the difference between the Value added (constant 2005 US$) of Belgium and Value added (constant 2005 US$) of Hungary?
Your answer should be compact. 5.65e+1. In the year 2005, what is the difference between the Value added (constant 2005 US$) of Belgium and Value added (constant 2005 US$) of Sao Tome and Principe?
Your answer should be very brief. 8.69e+1. In the year 2005, what is the difference between the Value added (constant 2005 US$) in Brazil and Value added (constant 2005 US$) in Hungary?
Make the answer very short. 1.86e+11. In the year 2005, what is the difference between the Value added (constant 2005 US$) of Brazil and Value added (constant 2005 US$) of Sao Tome and Principe?
Make the answer very short. 2.17e+11. In the year 2005, what is the difference between the Value added (constant 2005 US$) in Hungary and Value added (constant 2005 US$) in Sao Tome and Principe?
Your response must be concise. 3.04e+1. In the year 2006, what is the difference between the Value added (constant 2005 US$) in Belgium and Value added (constant 2005 US$) in Brazil?
Ensure brevity in your answer.  -1.38e+11. In the year 2006, what is the difference between the Value added (constant 2005 US$) of Belgium and Value added (constant 2005 US$) of Hungary?
Ensure brevity in your answer.  5.78e+1. In the year 2006, what is the difference between the Value added (constant 2005 US$) of Belgium and Value added (constant 2005 US$) of Sao Tome and Principe?
Keep it short and to the point. 8.95e+1. In the year 2006, what is the difference between the Value added (constant 2005 US$) in Brazil and Value added (constant 2005 US$) in Hungary?
Provide a short and direct response. 1.96e+11. In the year 2006, what is the difference between the Value added (constant 2005 US$) of Brazil and Value added (constant 2005 US$) of Sao Tome and Principe?
Offer a terse response. 2.28e+11. In the year 2006, what is the difference between the Value added (constant 2005 US$) in Hungary and Value added (constant 2005 US$) in Sao Tome and Principe?
Provide a succinct answer. 3.17e+1. In the year 2007, what is the difference between the Value added (constant 2005 US$) in Belgium and Value added (constant 2005 US$) in Brazil?
Offer a terse response. -1.53e+11. In the year 2007, what is the difference between the Value added (constant 2005 US$) in Belgium and Value added (constant 2005 US$) in Hungary?
Your response must be concise. 6.04e+1. In the year 2007, what is the difference between the Value added (constant 2005 US$) in Belgium and Value added (constant 2005 US$) in Sao Tome and Principe?
Give a very brief answer. 9.36e+1. In the year 2007, what is the difference between the Value added (constant 2005 US$) in Brazil and Value added (constant 2005 US$) in Hungary?
Keep it short and to the point. 2.13e+11. In the year 2007, what is the difference between the Value added (constant 2005 US$) in Brazil and Value added (constant 2005 US$) in Sao Tome and Principe?
Make the answer very short. 2.46e+11. In the year 2007, what is the difference between the Value added (constant 2005 US$) of Hungary and Value added (constant 2005 US$) of Sao Tome and Principe?
Make the answer very short. 3.32e+1. In the year 2008, what is the difference between the Value added (constant 2005 US$) in Belgium and Value added (constant 2005 US$) in Brazil?
Offer a very short reply. -1.66e+11. In the year 2008, what is the difference between the Value added (constant 2005 US$) of Belgium and Value added (constant 2005 US$) of Hungary?
Your answer should be compact. 6.15e+1. In the year 2008, what is the difference between the Value added (constant 2005 US$) of Belgium and Value added (constant 2005 US$) of Sao Tome and Principe?
Your answer should be compact. 9.30e+1. In the year 2008, what is the difference between the Value added (constant 2005 US$) in Brazil and Value added (constant 2005 US$) in Hungary?
Give a very brief answer. 2.28e+11. In the year 2008, what is the difference between the Value added (constant 2005 US$) in Brazil and Value added (constant 2005 US$) in Sao Tome and Principe?
Provide a succinct answer. 2.59e+11. In the year 2008, what is the difference between the Value added (constant 2005 US$) of Hungary and Value added (constant 2005 US$) of Sao Tome and Principe?
Your answer should be very brief. 3.15e+1. In the year 2009, what is the difference between the Value added (constant 2005 US$) of Belgium and Value added (constant 2005 US$) of Brazil?
Provide a short and direct response. -1.66e+11. In the year 2009, what is the difference between the Value added (constant 2005 US$) in Belgium and Value added (constant 2005 US$) in Hungary?
Give a very brief answer. 6.01e+1. In the year 2009, what is the difference between the Value added (constant 2005 US$) in Belgium and Value added (constant 2005 US$) in Sao Tome and Principe?
Provide a short and direct response. 8.77e+1. In the year 2009, what is the difference between the Value added (constant 2005 US$) in Brazil and Value added (constant 2005 US$) in Hungary?
Provide a succinct answer. 2.26e+11. In the year 2009, what is the difference between the Value added (constant 2005 US$) of Brazil and Value added (constant 2005 US$) of Sao Tome and Principe?
Keep it short and to the point. 2.53e+11. In the year 2009, what is the difference between the Value added (constant 2005 US$) in Hungary and Value added (constant 2005 US$) in Sao Tome and Principe?
Offer a terse response. 2.76e+1. In the year 2010, what is the difference between the Value added (constant 2005 US$) of Belgium and Value added (constant 2005 US$) of Brazil?
Your answer should be compact. -1.90e+11. In the year 2010, what is the difference between the Value added (constant 2005 US$) in Belgium and Value added (constant 2005 US$) in Hungary?
Provide a succinct answer. 6.28e+1. In the year 2010, what is the difference between the Value added (constant 2005 US$) of Belgium and Value added (constant 2005 US$) of Sao Tome and Principe?
Give a very brief answer. 9.17e+1. In the year 2010, what is the difference between the Value added (constant 2005 US$) in Brazil and Value added (constant 2005 US$) in Hungary?
Provide a succinct answer. 2.52e+11. In the year 2010, what is the difference between the Value added (constant 2005 US$) in Brazil and Value added (constant 2005 US$) in Sao Tome and Principe?
Provide a succinct answer. 2.81e+11. In the year 2010, what is the difference between the Value added (constant 2005 US$) in Hungary and Value added (constant 2005 US$) in Sao Tome and Principe?
Make the answer very short. 2.90e+1. In the year 2011, what is the difference between the Value added (constant 2005 US$) of Belgium and Value added (constant 2005 US$) of Brazil?
Make the answer very short. -1.94e+11. In the year 2011, what is the difference between the Value added (constant 2005 US$) of Belgium and Value added (constant 2005 US$) of Hungary?
Your answer should be very brief. 6.49e+1. In the year 2011, what is the difference between the Value added (constant 2005 US$) of Belgium and Value added (constant 2005 US$) of Sao Tome and Principe?
Provide a short and direct response. 9.40e+1. In the year 2011, what is the difference between the Value added (constant 2005 US$) of Brazil and Value added (constant 2005 US$) of Hungary?
Make the answer very short. 2.59e+11. In the year 2011, what is the difference between the Value added (constant 2005 US$) of Brazil and Value added (constant 2005 US$) of Sao Tome and Principe?
Keep it short and to the point. 2.88e+11. In the year 2011, what is the difference between the Value added (constant 2005 US$) in Hungary and Value added (constant 2005 US$) in Sao Tome and Principe?
Make the answer very short. 2.92e+1. What is the ratio of the Value added (constant 2005 US$) in Belgium in 2004 to that in 2005?
Your answer should be very brief. 0.98. What is the ratio of the Value added (constant 2005 US$) in Brazil in 2004 to that in 2005?
Give a very brief answer. 0.97. What is the ratio of the Value added (constant 2005 US$) in Hungary in 2004 to that in 2005?
Ensure brevity in your answer.  0.95. What is the ratio of the Value added (constant 2005 US$) in Sao Tome and Principe in 2004 to that in 2005?
Your answer should be very brief. 0.96. What is the ratio of the Value added (constant 2005 US$) of Belgium in 2004 to that in 2006?
Make the answer very short. 0.95. What is the ratio of the Value added (constant 2005 US$) of Brazil in 2004 to that in 2006?
Your answer should be compact. 0.93. What is the ratio of the Value added (constant 2005 US$) in Hungary in 2004 to that in 2006?
Offer a terse response. 0.91. What is the ratio of the Value added (constant 2005 US$) in Sao Tome and Principe in 2004 to that in 2006?
Offer a very short reply. 0.91. What is the ratio of the Value added (constant 2005 US$) of Belgium in 2004 to that in 2007?
Provide a short and direct response. 0.91. What is the ratio of the Value added (constant 2005 US$) in Brazil in 2004 to that in 2007?
Your response must be concise. 0.86. What is the ratio of the Value added (constant 2005 US$) in Hungary in 2004 to that in 2007?
Offer a very short reply. 0.87. What is the ratio of the Value added (constant 2005 US$) in Sao Tome and Principe in 2004 to that in 2007?
Offer a very short reply. 0.88. What is the ratio of the Value added (constant 2005 US$) of Belgium in 2004 to that in 2008?
Your answer should be very brief. 0.92. What is the ratio of the Value added (constant 2005 US$) in Brazil in 2004 to that in 2008?
Make the answer very short. 0.81. What is the ratio of the Value added (constant 2005 US$) in Hungary in 2004 to that in 2008?
Ensure brevity in your answer.  0.92. What is the ratio of the Value added (constant 2005 US$) of Sao Tome and Principe in 2004 to that in 2008?
Your response must be concise. 0.83. What is the ratio of the Value added (constant 2005 US$) of Belgium in 2004 to that in 2009?
Ensure brevity in your answer.  0.97. What is the ratio of the Value added (constant 2005 US$) of Brazil in 2004 to that in 2009?
Your response must be concise. 0.83. What is the ratio of the Value added (constant 2005 US$) in Hungary in 2004 to that in 2009?
Offer a terse response. 1.05. What is the ratio of the Value added (constant 2005 US$) of Sao Tome and Principe in 2004 to that in 2009?
Your answer should be compact. 0.83. What is the ratio of the Value added (constant 2005 US$) of Belgium in 2004 to that in 2010?
Your answer should be very brief. 0.93. What is the ratio of the Value added (constant 2005 US$) of Brazil in 2004 to that in 2010?
Provide a short and direct response. 0.75. What is the ratio of the Value added (constant 2005 US$) in Hungary in 2004 to that in 2010?
Offer a very short reply. 1. What is the ratio of the Value added (constant 2005 US$) of Sao Tome and Principe in 2004 to that in 2010?
Provide a succinct answer. 0.81. What is the ratio of the Value added (constant 2005 US$) of Belgium in 2004 to that in 2011?
Make the answer very short. 0.91. What is the ratio of the Value added (constant 2005 US$) in Brazil in 2004 to that in 2011?
Your response must be concise. 0.73. What is the ratio of the Value added (constant 2005 US$) of Sao Tome and Principe in 2004 to that in 2011?
Provide a short and direct response. 0.77. What is the ratio of the Value added (constant 2005 US$) in Belgium in 2005 to that in 2006?
Provide a short and direct response. 0.97. What is the ratio of the Value added (constant 2005 US$) of Brazil in 2005 to that in 2006?
Provide a succinct answer. 0.95. What is the ratio of the Value added (constant 2005 US$) of Hungary in 2005 to that in 2006?
Keep it short and to the point. 0.96. What is the ratio of the Value added (constant 2005 US$) in Sao Tome and Principe in 2005 to that in 2006?
Keep it short and to the point. 0.94. What is the ratio of the Value added (constant 2005 US$) of Belgium in 2005 to that in 2007?
Offer a very short reply. 0.93. What is the ratio of the Value added (constant 2005 US$) in Brazil in 2005 to that in 2007?
Ensure brevity in your answer.  0.88. What is the ratio of the Value added (constant 2005 US$) in Hungary in 2005 to that in 2007?
Give a very brief answer. 0.92. What is the ratio of the Value added (constant 2005 US$) in Sao Tome and Principe in 2005 to that in 2007?
Offer a terse response. 0.91. What is the ratio of the Value added (constant 2005 US$) in Belgium in 2005 to that in 2008?
Keep it short and to the point. 0.93. What is the ratio of the Value added (constant 2005 US$) in Brazil in 2005 to that in 2008?
Ensure brevity in your answer.  0.84. What is the ratio of the Value added (constant 2005 US$) in Hungary in 2005 to that in 2008?
Your answer should be compact. 0.97. What is the ratio of the Value added (constant 2005 US$) of Sao Tome and Principe in 2005 to that in 2008?
Provide a short and direct response. 0.86. What is the ratio of the Value added (constant 2005 US$) of Belgium in 2005 to that in 2009?
Ensure brevity in your answer.  0.99. What is the ratio of the Value added (constant 2005 US$) in Brazil in 2005 to that in 2009?
Your answer should be very brief. 0.86. What is the ratio of the Value added (constant 2005 US$) in Hungary in 2005 to that in 2009?
Your answer should be very brief. 1.1. What is the ratio of the Value added (constant 2005 US$) in Sao Tome and Principe in 2005 to that in 2009?
Offer a very short reply. 0.86. What is the ratio of the Value added (constant 2005 US$) of Brazil in 2005 to that in 2010?
Provide a short and direct response. 0.77. What is the ratio of the Value added (constant 2005 US$) of Hungary in 2005 to that in 2010?
Your response must be concise. 1.05. What is the ratio of the Value added (constant 2005 US$) of Sao Tome and Principe in 2005 to that in 2010?
Offer a very short reply. 0.84. What is the ratio of the Value added (constant 2005 US$) of Belgium in 2005 to that in 2011?
Keep it short and to the point. 0.92. What is the ratio of the Value added (constant 2005 US$) of Brazil in 2005 to that in 2011?
Provide a succinct answer. 0.75. What is the ratio of the Value added (constant 2005 US$) in Hungary in 2005 to that in 2011?
Keep it short and to the point. 1.04. What is the ratio of the Value added (constant 2005 US$) in Sao Tome and Principe in 2005 to that in 2011?
Provide a short and direct response. 0.8. What is the ratio of the Value added (constant 2005 US$) in Belgium in 2006 to that in 2007?
Make the answer very short. 0.96. What is the ratio of the Value added (constant 2005 US$) of Brazil in 2006 to that in 2007?
Your answer should be very brief. 0.92. What is the ratio of the Value added (constant 2005 US$) of Hungary in 2006 to that in 2007?
Offer a terse response. 0.95. What is the ratio of the Value added (constant 2005 US$) in Sao Tome and Principe in 2006 to that in 2007?
Give a very brief answer. 0.97. What is the ratio of the Value added (constant 2005 US$) of Belgium in 2006 to that in 2008?
Your response must be concise. 0.96. What is the ratio of the Value added (constant 2005 US$) in Brazil in 2006 to that in 2008?
Ensure brevity in your answer.  0.88. What is the ratio of the Value added (constant 2005 US$) in Hungary in 2006 to that in 2008?
Keep it short and to the point. 1.01. What is the ratio of the Value added (constant 2005 US$) in Sao Tome and Principe in 2006 to that in 2008?
Offer a very short reply. 0.92. What is the ratio of the Value added (constant 2005 US$) in Brazil in 2006 to that in 2009?
Your response must be concise. 0.9. What is the ratio of the Value added (constant 2005 US$) in Hungary in 2006 to that in 2009?
Provide a short and direct response. 1.15. What is the ratio of the Value added (constant 2005 US$) in Sao Tome and Principe in 2006 to that in 2009?
Give a very brief answer. 0.91. What is the ratio of the Value added (constant 2005 US$) in Belgium in 2006 to that in 2010?
Your answer should be compact. 0.98. What is the ratio of the Value added (constant 2005 US$) in Brazil in 2006 to that in 2010?
Provide a succinct answer. 0.81. What is the ratio of the Value added (constant 2005 US$) in Hungary in 2006 to that in 2010?
Provide a succinct answer. 1.09. What is the ratio of the Value added (constant 2005 US$) in Sao Tome and Principe in 2006 to that in 2010?
Provide a short and direct response. 0.89. What is the ratio of the Value added (constant 2005 US$) of Brazil in 2006 to that in 2011?
Ensure brevity in your answer.  0.79. What is the ratio of the Value added (constant 2005 US$) in Hungary in 2006 to that in 2011?
Provide a short and direct response. 1.09. What is the ratio of the Value added (constant 2005 US$) in Sao Tome and Principe in 2006 to that in 2011?
Offer a very short reply. 0.85. What is the ratio of the Value added (constant 2005 US$) of Belgium in 2007 to that in 2008?
Offer a very short reply. 1.01. What is the ratio of the Value added (constant 2005 US$) of Brazil in 2007 to that in 2008?
Keep it short and to the point. 0.95. What is the ratio of the Value added (constant 2005 US$) of Hungary in 2007 to that in 2008?
Ensure brevity in your answer.  1.06. What is the ratio of the Value added (constant 2005 US$) of Sao Tome and Principe in 2007 to that in 2008?
Keep it short and to the point. 0.94. What is the ratio of the Value added (constant 2005 US$) of Belgium in 2007 to that in 2009?
Your answer should be compact. 1.07. What is the ratio of the Value added (constant 2005 US$) of Brazil in 2007 to that in 2009?
Your response must be concise. 0.97. What is the ratio of the Value added (constant 2005 US$) of Hungary in 2007 to that in 2009?
Keep it short and to the point. 1.2. What is the ratio of the Value added (constant 2005 US$) of Sao Tome and Principe in 2007 to that in 2009?
Ensure brevity in your answer.  0.94. What is the ratio of the Value added (constant 2005 US$) of Belgium in 2007 to that in 2010?
Provide a short and direct response. 1.02. What is the ratio of the Value added (constant 2005 US$) in Brazil in 2007 to that in 2010?
Provide a succinct answer. 0.88. What is the ratio of the Value added (constant 2005 US$) of Hungary in 2007 to that in 2010?
Your response must be concise. 1.15. What is the ratio of the Value added (constant 2005 US$) in Sao Tome and Principe in 2007 to that in 2010?
Provide a short and direct response. 0.92. What is the ratio of the Value added (constant 2005 US$) of Belgium in 2007 to that in 2011?
Offer a very short reply. 1. What is the ratio of the Value added (constant 2005 US$) of Brazil in 2007 to that in 2011?
Give a very brief answer. 0.86. What is the ratio of the Value added (constant 2005 US$) of Hungary in 2007 to that in 2011?
Provide a short and direct response. 1.14. What is the ratio of the Value added (constant 2005 US$) in Sao Tome and Principe in 2007 to that in 2011?
Offer a very short reply. 0.87. What is the ratio of the Value added (constant 2005 US$) in Belgium in 2008 to that in 2009?
Your answer should be compact. 1.06. What is the ratio of the Value added (constant 2005 US$) in Brazil in 2008 to that in 2009?
Your response must be concise. 1.02. What is the ratio of the Value added (constant 2005 US$) in Hungary in 2008 to that in 2009?
Give a very brief answer. 1.14. What is the ratio of the Value added (constant 2005 US$) in Sao Tome and Principe in 2008 to that in 2009?
Your answer should be compact. 0.99. What is the ratio of the Value added (constant 2005 US$) in Belgium in 2008 to that in 2010?
Keep it short and to the point. 1.01. What is the ratio of the Value added (constant 2005 US$) in Brazil in 2008 to that in 2010?
Provide a succinct answer. 0.92. What is the ratio of the Value added (constant 2005 US$) in Hungary in 2008 to that in 2010?
Your answer should be very brief. 1.09. What is the ratio of the Value added (constant 2005 US$) in Sao Tome and Principe in 2008 to that in 2010?
Your answer should be compact. 0.97. What is the ratio of the Value added (constant 2005 US$) of Belgium in 2008 to that in 2011?
Your answer should be compact. 0.99. What is the ratio of the Value added (constant 2005 US$) in Brazil in 2008 to that in 2011?
Offer a very short reply. 0.9. What is the ratio of the Value added (constant 2005 US$) in Hungary in 2008 to that in 2011?
Provide a succinct answer. 1.08. What is the ratio of the Value added (constant 2005 US$) in Sao Tome and Principe in 2008 to that in 2011?
Give a very brief answer. 0.92. What is the ratio of the Value added (constant 2005 US$) of Belgium in 2009 to that in 2010?
Provide a succinct answer. 0.96. What is the ratio of the Value added (constant 2005 US$) in Brazil in 2009 to that in 2010?
Offer a very short reply. 0.9. What is the ratio of the Value added (constant 2005 US$) of Hungary in 2009 to that in 2010?
Your answer should be very brief. 0.95. What is the ratio of the Value added (constant 2005 US$) of Sao Tome and Principe in 2009 to that in 2010?
Offer a very short reply. 0.98. What is the ratio of the Value added (constant 2005 US$) of Belgium in 2009 to that in 2011?
Provide a short and direct response. 0.93. What is the ratio of the Value added (constant 2005 US$) in Brazil in 2009 to that in 2011?
Offer a terse response. 0.88. What is the ratio of the Value added (constant 2005 US$) in Hungary in 2009 to that in 2011?
Offer a very short reply. 0.95. What is the ratio of the Value added (constant 2005 US$) in Sao Tome and Principe in 2009 to that in 2011?
Your answer should be very brief. 0.93. What is the ratio of the Value added (constant 2005 US$) in Belgium in 2010 to that in 2011?
Provide a short and direct response. 0.98. What is the ratio of the Value added (constant 2005 US$) in Brazil in 2010 to that in 2011?
Offer a terse response. 0.98. What is the ratio of the Value added (constant 2005 US$) of Hungary in 2010 to that in 2011?
Make the answer very short. 0.99. What is the ratio of the Value added (constant 2005 US$) of Sao Tome and Principe in 2010 to that in 2011?
Give a very brief answer. 0.95. What is the difference between the highest and the second highest Value added (constant 2005 US$) of Belgium?
Provide a short and direct response. 4.31e+08. What is the difference between the highest and the second highest Value added (constant 2005 US$) of Brazil?
Provide a short and direct response. 6.54e+09. What is the difference between the highest and the second highest Value added (constant 2005 US$) of Hungary?
Your answer should be compact. 1.53e+09. What is the difference between the highest and the second highest Value added (constant 2005 US$) of Sao Tome and Principe?
Your answer should be very brief. 1.21e+06. What is the difference between the highest and the lowest Value added (constant 2005 US$) in Belgium?
Make the answer very short. 8.80e+09. What is the difference between the highest and the lowest Value added (constant 2005 US$) in Brazil?
Offer a very short reply. 7.73e+1. What is the difference between the highest and the lowest Value added (constant 2005 US$) of Hungary?
Your response must be concise. 5.64e+09. What is the difference between the highest and the lowest Value added (constant 2005 US$) in Sao Tome and Principe?
Give a very brief answer. 5.57e+06. 